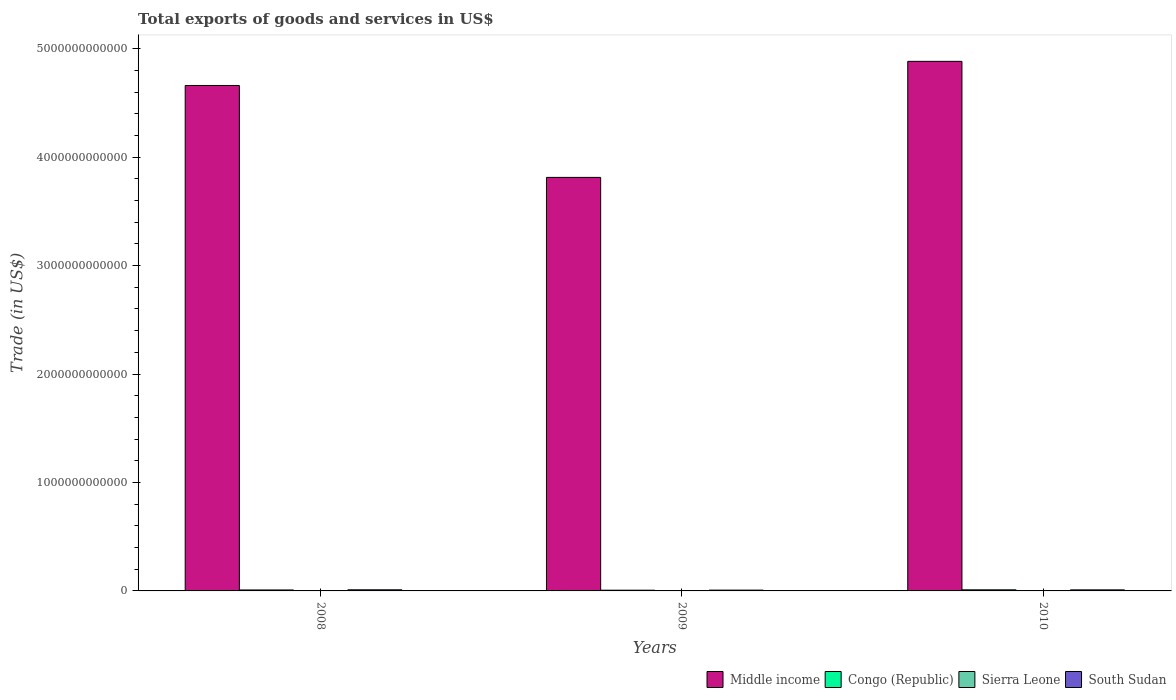Are the number of bars on each tick of the X-axis equal?
Your answer should be compact. Yes. How many bars are there on the 2nd tick from the left?
Give a very brief answer. 4. How many bars are there on the 1st tick from the right?
Ensure brevity in your answer.  4. In how many cases, is the number of bars for a given year not equal to the number of legend labels?
Make the answer very short. 0. What is the total exports of goods and services in Middle income in 2009?
Keep it short and to the point. 3.81e+12. Across all years, what is the maximum total exports of goods and services in Middle income?
Give a very brief answer. 4.88e+12. Across all years, what is the minimum total exports of goods and services in Sierra Leone?
Make the answer very short. 3.31e+08. What is the total total exports of goods and services in Congo (Republic) in the graph?
Give a very brief answer. 2.59e+1. What is the difference between the total exports of goods and services in Middle income in 2009 and that in 2010?
Your answer should be compact. -1.07e+12. What is the difference between the total exports of goods and services in South Sudan in 2010 and the total exports of goods and services in Sierra Leone in 2009?
Make the answer very short. 9.33e+09. What is the average total exports of goods and services in Sierra Leone per year?
Your answer should be compact. 3.68e+08. In the year 2008, what is the difference between the total exports of goods and services in South Sudan and total exports of goods and services in Sierra Leone?
Your response must be concise. 9.93e+09. In how many years, is the total exports of goods and services in Middle income greater than 1800000000000 US$?
Your answer should be compact. 3. What is the ratio of the total exports of goods and services in South Sudan in 2009 to that in 2010?
Your answer should be compact. 0.76. Is the total exports of goods and services in Middle income in 2009 less than that in 2010?
Provide a succinct answer. Yes. Is the difference between the total exports of goods and services in South Sudan in 2009 and 2010 greater than the difference between the total exports of goods and services in Sierra Leone in 2009 and 2010?
Your answer should be compact. No. What is the difference between the highest and the second highest total exports of goods and services in Middle income?
Give a very brief answer. 2.22e+11. What is the difference between the highest and the lowest total exports of goods and services in Sierra Leone?
Give a very brief answer. 1.02e+08. In how many years, is the total exports of goods and services in Middle income greater than the average total exports of goods and services in Middle income taken over all years?
Offer a very short reply. 2. What does the 1st bar from the left in 2009 represents?
Your answer should be very brief. Middle income. What does the 2nd bar from the right in 2008 represents?
Offer a very short reply. Sierra Leone. Is it the case that in every year, the sum of the total exports of goods and services in South Sudan and total exports of goods and services in Sierra Leone is greater than the total exports of goods and services in Middle income?
Provide a succinct answer. No. How many bars are there?
Your answer should be compact. 12. How many years are there in the graph?
Make the answer very short. 3. What is the difference between two consecutive major ticks on the Y-axis?
Offer a very short reply. 1.00e+12. Are the values on the major ticks of Y-axis written in scientific E-notation?
Your answer should be compact. No. Does the graph contain any zero values?
Provide a short and direct response. No. Does the graph contain grids?
Your answer should be very brief. No. What is the title of the graph?
Offer a terse response. Total exports of goods and services in US$. What is the label or title of the Y-axis?
Your answer should be compact. Trade (in US$). What is the Trade (in US$) in Middle income in 2008?
Your answer should be compact. 4.66e+12. What is the Trade (in US$) of Congo (Republic) in 2008?
Offer a very short reply. 8.91e+09. What is the Trade (in US$) in Sierra Leone in 2008?
Offer a very short reply. 3.39e+08. What is the Trade (in US$) in South Sudan in 2008?
Offer a terse response. 1.03e+1. What is the Trade (in US$) in Middle income in 2009?
Provide a short and direct response. 3.81e+12. What is the Trade (in US$) of Congo (Republic) in 2009?
Your answer should be very brief. 6.76e+09. What is the Trade (in US$) in Sierra Leone in 2009?
Make the answer very short. 3.31e+08. What is the Trade (in US$) of South Sudan in 2009?
Keep it short and to the point. 7.38e+09. What is the Trade (in US$) in Middle income in 2010?
Ensure brevity in your answer.  4.88e+12. What is the Trade (in US$) of Congo (Republic) in 2010?
Keep it short and to the point. 1.02e+1. What is the Trade (in US$) of Sierra Leone in 2010?
Make the answer very short. 4.33e+08. What is the Trade (in US$) of South Sudan in 2010?
Offer a terse response. 9.66e+09. Across all years, what is the maximum Trade (in US$) of Middle income?
Keep it short and to the point. 4.88e+12. Across all years, what is the maximum Trade (in US$) in Congo (Republic)?
Give a very brief answer. 1.02e+1. Across all years, what is the maximum Trade (in US$) of Sierra Leone?
Offer a very short reply. 4.33e+08. Across all years, what is the maximum Trade (in US$) of South Sudan?
Give a very brief answer. 1.03e+1. Across all years, what is the minimum Trade (in US$) of Middle income?
Offer a terse response. 3.81e+12. Across all years, what is the minimum Trade (in US$) of Congo (Republic)?
Your response must be concise. 6.76e+09. Across all years, what is the minimum Trade (in US$) of Sierra Leone?
Provide a succinct answer. 3.31e+08. Across all years, what is the minimum Trade (in US$) of South Sudan?
Offer a terse response. 7.38e+09. What is the total Trade (in US$) in Middle income in the graph?
Provide a short and direct response. 1.34e+13. What is the total Trade (in US$) of Congo (Republic) in the graph?
Provide a succinct answer. 2.59e+1. What is the total Trade (in US$) of Sierra Leone in the graph?
Provide a short and direct response. 1.10e+09. What is the total Trade (in US$) in South Sudan in the graph?
Your response must be concise. 2.73e+1. What is the difference between the Trade (in US$) in Middle income in 2008 and that in 2009?
Make the answer very short. 8.48e+11. What is the difference between the Trade (in US$) in Congo (Republic) in 2008 and that in 2009?
Offer a terse response. 2.16e+09. What is the difference between the Trade (in US$) of Sierra Leone in 2008 and that in 2009?
Your answer should be compact. 7.45e+06. What is the difference between the Trade (in US$) in South Sudan in 2008 and that in 2009?
Keep it short and to the point. 2.89e+09. What is the difference between the Trade (in US$) of Middle income in 2008 and that in 2010?
Keep it short and to the point. -2.22e+11. What is the difference between the Trade (in US$) of Congo (Republic) in 2008 and that in 2010?
Offer a terse response. -1.31e+09. What is the difference between the Trade (in US$) in Sierra Leone in 2008 and that in 2010?
Ensure brevity in your answer.  -9.43e+07. What is the difference between the Trade (in US$) in South Sudan in 2008 and that in 2010?
Provide a short and direct response. 6.05e+08. What is the difference between the Trade (in US$) of Middle income in 2009 and that in 2010?
Keep it short and to the point. -1.07e+12. What is the difference between the Trade (in US$) of Congo (Republic) in 2009 and that in 2010?
Your answer should be very brief. -3.47e+09. What is the difference between the Trade (in US$) in Sierra Leone in 2009 and that in 2010?
Keep it short and to the point. -1.02e+08. What is the difference between the Trade (in US$) in South Sudan in 2009 and that in 2010?
Ensure brevity in your answer.  -2.28e+09. What is the difference between the Trade (in US$) in Middle income in 2008 and the Trade (in US$) in Congo (Republic) in 2009?
Ensure brevity in your answer.  4.65e+12. What is the difference between the Trade (in US$) of Middle income in 2008 and the Trade (in US$) of Sierra Leone in 2009?
Provide a short and direct response. 4.66e+12. What is the difference between the Trade (in US$) of Middle income in 2008 and the Trade (in US$) of South Sudan in 2009?
Your answer should be very brief. 4.65e+12. What is the difference between the Trade (in US$) of Congo (Republic) in 2008 and the Trade (in US$) of Sierra Leone in 2009?
Your response must be concise. 8.58e+09. What is the difference between the Trade (in US$) in Congo (Republic) in 2008 and the Trade (in US$) in South Sudan in 2009?
Provide a short and direct response. 1.53e+09. What is the difference between the Trade (in US$) of Sierra Leone in 2008 and the Trade (in US$) of South Sudan in 2009?
Your answer should be very brief. -7.04e+09. What is the difference between the Trade (in US$) in Middle income in 2008 and the Trade (in US$) in Congo (Republic) in 2010?
Your answer should be compact. 4.65e+12. What is the difference between the Trade (in US$) in Middle income in 2008 and the Trade (in US$) in Sierra Leone in 2010?
Provide a succinct answer. 4.66e+12. What is the difference between the Trade (in US$) of Middle income in 2008 and the Trade (in US$) of South Sudan in 2010?
Your answer should be compact. 4.65e+12. What is the difference between the Trade (in US$) in Congo (Republic) in 2008 and the Trade (in US$) in Sierra Leone in 2010?
Keep it short and to the point. 8.48e+09. What is the difference between the Trade (in US$) of Congo (Republic) in 2008 and the Trade (in US$) of South Sudan in 2010?
Offer a very short reply. -7.50e+08. What is the difference between the Trade (in US$) of Sierra Leone in 2008 and the Trade (in US$) of South Sudan in 2010?
Make the answer very short. -9.32e+09. What is the difference between the Trade (in US$) of Middle income in 2009 and the Trade (in US$) of Congo (Republic) in 2010?
Your answer should be very brief. 3.80e+12. What is the difference between the Trade (in US$) of Middle income in 2009 and the Trade (in US$) of Sierra Leone in 2010?
Offer a very short reply. 3.81e+12. What is the difference between the Trade (in US$) of Middle income in 2009 and the Trade (in US$) of South Sudan in 2010?
Your answer should be very brief. 3.80e+12. What is the difference between the Trade (in US$) of Congo (Republic) in 2009 and the Trade (in US$) of Sierra Leone in 2010?
Offer a terse response. 6.32e+09. What is the difference between the Trade (in US$) in Congo (Republic) in 2009 and the Trade (in US$) in South Sudan in 2010?
Give a very brief answer. -2.91e+09. What is the difference between the Trade (in US$) of Sierra Leone in 2009 and the Trade (in US$) of South Sudan in 2010?
Keep it short and to the point. -9.33e+09. What is the average Trade (in US$) of Middle income per year?
Your response must be concise. 4.45e+12. What is the average Trade (in US$) of Congo (Republic) per year?
Provide a short and direct response. 8.63e+09. What is the average Trade (in US$) in Sierra Leone per year?
Give a very brief answer. 3.68e+08. What is the average Trade (in US$) in South Sudan per year?
Provide a short and direct response. 9.10e+09. In the year 2008, what is the difference between the Trade (in US$) of Middle income and Trade (in US$) of Congo (Republic)?
Your answer should be very brief. 4.65e+12. In the year 2008, what is the difference between the Trade (in US$) in Middle income and Trade (in US$) in Sierra Leone?
Your answer should be compact. 4.66e+12. In the year 2008, what is the difference between the Trade (in US$) of Middle income and Trade (in US$) of South Sudan?
Your answer should be compact. 4.65e+12. In the year 2008, what is the difference between the Trade (in US$) in Congo (Republic) and Trade (in US$) in Sierra Leone?
Make the answer very short. 8.57e+09. In the year 2008, what is the difference between the Trade (in US$) of Congo (Republic) and Trade (in US$) of South Sudan?
Make the answer very short. -1.36e+09. In the year 2008, what is the difference between the Trade (in US$) in Sierra Leone and Trade (in US$) in South Sudan?
Keep it short and to the point. -9.93e+09. In the year 2009, what is the difference between the Trade (in US$) in Middle income and Trade (in US$) in Congo (Republic)?
Your answer should be compact. 3.81e+12. In the year 2009, what is the difference between the Trade (in US$) in Middle income and Trade (in US$) in Sierra Leone?
Your answer should be very brief. 3.81e+12. In the year 2009, what is the difference between the Trade (in US$) of Middle income and Trade (in US$) of South Sudan?
Make the answer very short. 3.81e+12. In the year 2009, what is the difference between the Trade (in US$) in Congo (Republic) and Trade (in US$) in Sierra Leone?
Provide a succinct answer. 6.42e+09. In the year 2009, what is the difference between the Trade (in US$) in Congo (Republic) and Trade (in US$) in South Sudan?
Provide a short and direct response. -6.22e+08. In the year 2009, what is the difference between the Trade (in US$) in Sierra Leone and Trade (in US$) in South Sudan?
Keep it short and to the point. -7.05e+09. In the year 2010, what is the difference between the Trade (in US$) in Middle income and Trade (in US$) in Congo (Republic)?
Make the answer very short. 4.87e+12. In the year 2010, what is the difference between the Trade (in US$) of Middle income and Trade (in US$) of Sierra Leone?
Offer a very short reply. 4.88e+12. In the year 2010, what is the difference between the Trade (in US$) in Middle income and Trade (in US$) in South Sudan?
Provide a short and direct response. 4.87e+12. In the year 2010, what is the difference between the Trade (in US$) in Congo (Republic) and Trade (in US$) in Sierra Leone?
Offer a very short reply. 9.79e+09. In the year 2010, what is the difference between the Trade (in US$) of Congo (Republic) and Trade (in US$) of South Sudan?
Provide a succinct answer. 5.59e+08. In the year 2010, what is the difference between the Trade (in US$) in Sierra Leone and Trade (in US$) in South Sudan?
Ensure brevity in your answer.  -9.23e+09. What is the ratio of the Trade (in US$) of Middle income in 2008 to that in 2009?
Provide a succinct answer. 1.22. What is the ratio of the Trade (in US$) of Congo (Republic) in 2008 to that in 2009?
Provide a succinct answer. 1.32. What is the ratio of the Trade (in US$) of Sierra Leone in 2008 to that in 2009?
Provide a short and direct response. 1.02. What is the ratio of the Trade (in US$) in South Sudan in 2008 to that in 2009?
Ensure brevity in your answer.  1.39. What is the ratio of the Trade (in US$) of Middle income in 2008 to that in 2010?
Make the answer very short. 0.95. What is the ratio of the Trade (in US$) in Congo (Republic) in 2008 to that in 2010?
Your response must be concise. 0.87. What is the ratio of the Trade (in US$) in Sierra Leone in 2008 to that in 2010?
Keep it short and to the point. 0.78. What is the ratio of the Trade (in US$) of South Sudan in 2008 to that in 2010?
Your answer should be very brief. 1.06. What is the ratio of the Trade (in US$) of Middle income in 2009 to that in 2010?
Ensure brevity in your answer.  0.78. What is the ratio of the Trade (in US$) in Congo (Republic) in 2009 to that in 2010?
Make the answer very short. 0.66. What is the ratio of the Trade (in US$) of Sierra Leone in 2009 to that in 2010?
Offer a very short reply. 0.77. What is the ratio of the Trade (in US$) in South Sudan in 2009 to that in 2010?
Give a very brief answer. 0.76. What is the difference between the highest and the second highest Trade (in US$) in Middle income?
Ensure brevity in your answer.  2.22e+11. What is the difference between the highest and the second highest Trade (in US$) in Congo (Republic)?
Your answer should be compact. 1.31e+09. What is the difference between the highest and the second highest Trade (in US$) in Sierra Leone?
Provide a succinct answer. 9.43e+07. What is the difference between the highest and the second highest Trade (in US$) of South Sudan?
Make the answer very short. 6.05e+08. What is the difference between the highest and the lowest Trade (in US$) of Middle income?
Make the answer very short. 1.07e+12. What is the difference between the highest and the lowest Trade (in US$) of Congo (Republic)?
Offer a terse response. 3.47e+09. What is the difference between the highest and the lowest Trade (in US$) of Sierra Leone?
Offer a very short reply. 1.02e+08. What is the difference between the highest and the lowest Trade (in US$) of South Sudan?
Keep it short and to the point. 2.89e+09. 